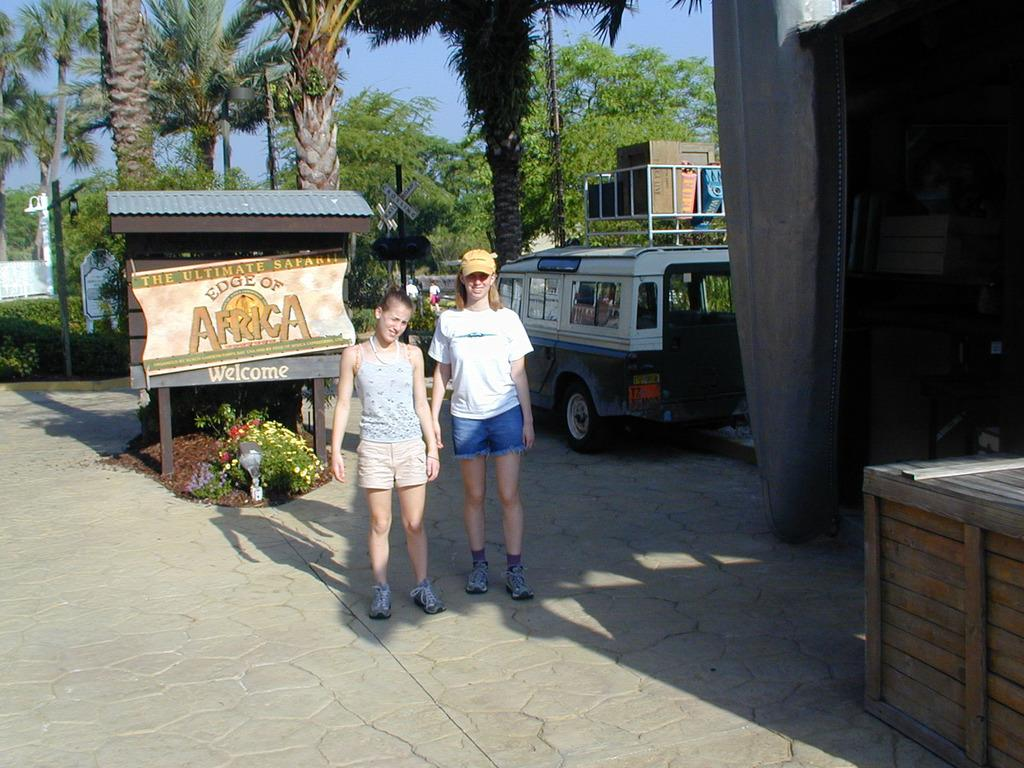<image>
Write a terse but informative summary of the picture. Two kids pose in front of a sign that says The Ultimate Safari. 